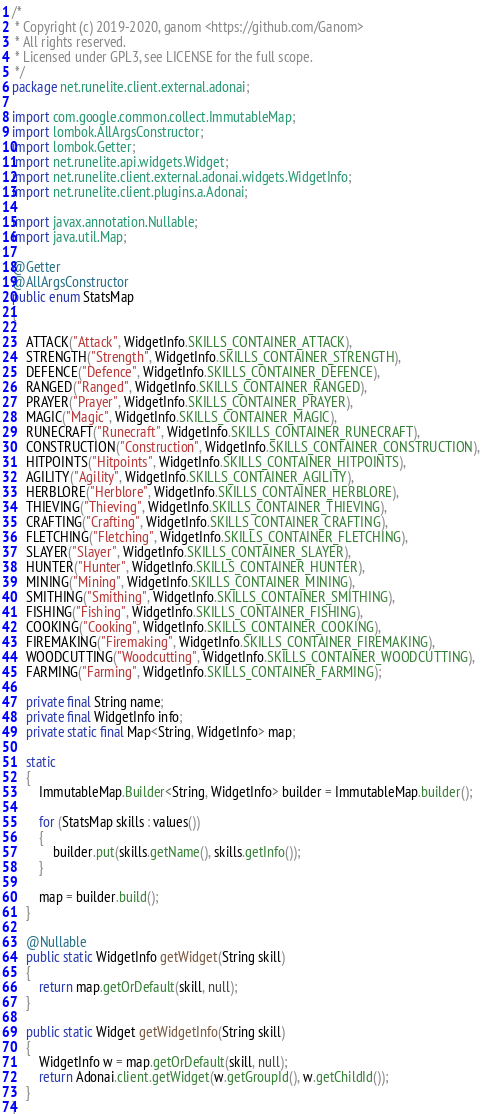<code> <loc_0><loc_0><loc_500><loc_500><_Java_>/*
 * Copyright (c) 2019-2020, ganom <https://github.com/Ganom>
 * All rights reserved.
 * Licensed under GPL3, see LICENSE for the full scope.
 */
package net.runelite.client.external.adonai;

import com.google.common.collect.ImmutableMap;
import lombok.AllArgsConstructor;
import lombok.Getter;
import net.runelite.api.widgets.Widget;
import net.runelite.client.external.adonai.widgets.WidgetInfo;
import net.runelite.client.plugins.a.Adonai;

import javax.annotation.Nullable;
import java.util.Map;

@Getter
@AllArgsConstructor
public enum StatsMap
{

	ATTACK("Attack", WidgetInfo.SKILLS_CONTAINER_ATTACK),
	STRENGTH("Strength", WidgetInfo.SKILLS_CONTAINER_STRENGTH),
	DEFENCE("Defence", WidgetInfo.SKILLS_CONTAINER_DEFENCE),
	RANGED("Ranged", WidgetInfo.SKILLS_CONTAINER_RANGED),
	PRAYER("Prayer", WidgetInfo.SKILLS_CONTAINER_PRAYER),
	MAGIC("Magic", WidgetInfo.SKILLS_CONTAINER_MAGIC),
	RUNECRAFT("Runecraft", WidgetInfo.SKILLS_CONTAINER_RUNECRAFT),
	CONSTRUCTION("Construction", WidgetInfo.SKILLS_CONTAINER_CONSTRUCTION),
	HITPOINTS("Hitpoints", WidgetInfo.SKILLS_CONTAINER_HITPOINTS),
	AGILITY("Agility", WidgetInfo.SKILLS_CONTAINER_AGILITY),
	HERBLORE("Herblore", WidgetInfo.SKILLS_CONTAINER_HERBLORE),
	THIEVING("Thieving", WidgetInfo.SKILLS_CONTAINER_THIEVING),
	CRAFTING("Crafting", WidgetInfo.SKILLS_CONTAINER_CRAFTING),
	FLETCHING("Fletching", WidgetInfo.SKILLS_CONTAINER_FLETCHING),
	SLAYER("Slayer", WidgetInfo.SKILLS_CONTAINER_SLAYER),
	HUNTER("Hunter", WidgetInfo.SKILLS_CONTAINER_HUNTER),
	MINING("Mining", WidgetInfo.SKILLS_CONTAINER_MINING),
	SMITHING("Smithing", WidgetInfo.SKILLS_CONTAINER_SMITHING),
	FISHING("Fishing", WidgetInfo.SKILLS_CONTAINER_FISHING),
	COOKING("Cooking", WidgetInfo.SKILLS_CONTAINER_COOKING),
	FIREMAKING("Firemaking", WidgetInfo.SKILLS_CONTAINER_FIREMAKING),
	WOODCUTTING("Woodcutting", WidgetInfo.SKILLS_CONTAINER_WOODCUTTING),
	FARMING("Farming", WidgetInfo.SKILLS_CONTAINER_FARMING);

	private final String name;
	private final WidgetInfo info;
	private static final Map<String, WidgetInfo> map;

	static
	{
		ImmutableMap.Builder<String, WidgetInfo> builder = ImmutableMap.builder();

		for (StatsMap skills : values())
		{
			builder.put(skills.getName(), skills.getInfo());
		}

		map = builder.build();
	}

	@Nullable
	public static WidgetInfo getWidget(String skill)
	{
		return map.getOrDefault(skill, null);
	}

	public static Widget getWidgetInfo(String skill)
	{
		WidgetInfo w = map.getOrDefault(skill, null);
		return Adonai.client.getWidget(w.getGroupId(), w.getChildId());
	}
}
</code> 